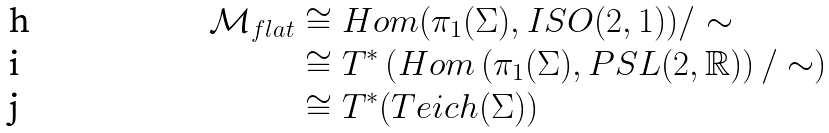Convert formula to latex. <formula><loc_0><loc_0><loc_500><loc_500>\mathcal { M } _ { f l a t } & \cong H o m ( \pi _ { 1 } ( \Sigma ) , I S O ( 2 , 1 ) ) / \sim \\ & \cong T ^ { * } \left ( H o m \left ( \pi _ { 1 } ( \Sigma ) , P S L ( 2 , \mathbb { R } ) \right ) / \sim \right ) \\ & \cong T ^ { * } ( T e i c h ( \Sigma ) )</formula> 